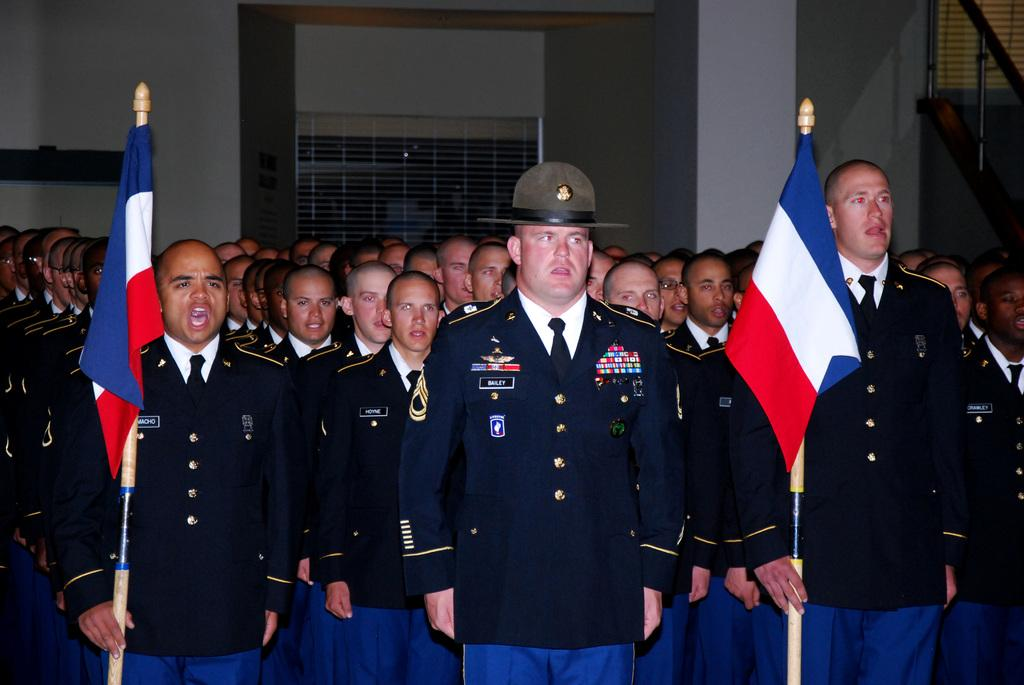What are the people in the image doing? There are people standing in the image, and two men are holding flag poles. What can be seen in the background of the image? There is a wall and a railing in the background of the image, along with other objects. What type of leaf is being used as a prop by the actor in the image? There is no actor or leaf present in the image. What game are the people playing in the image? There is no indication of a game being played in the image; the people are holding flag poles. 